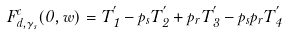Convert formula to latex. <formula><loc_0><loc_0><loc_500><loc_500>F ^ { c } _ { d , \gamma _ { s } } ( 0 , w ) = T _ { 1 } ^ { ^ { \prime } } - p _ { s } T _ { 2 } ^ { ^ { \prime } } + p _ { r } T _ { 3 } ^ { ^ { \prime } } - p _ { s } p _ { r } T _ { 4 } ^ { ^ { \prime } }</formula> 